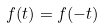Convert formula to latex. <formula><loc_0><loc_0><loc_500><loc_500>f ( t ) = f ( - t )</formula> 